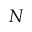<formula> <loc_0><loc_0><loc_500><loc_500>N</formula> 